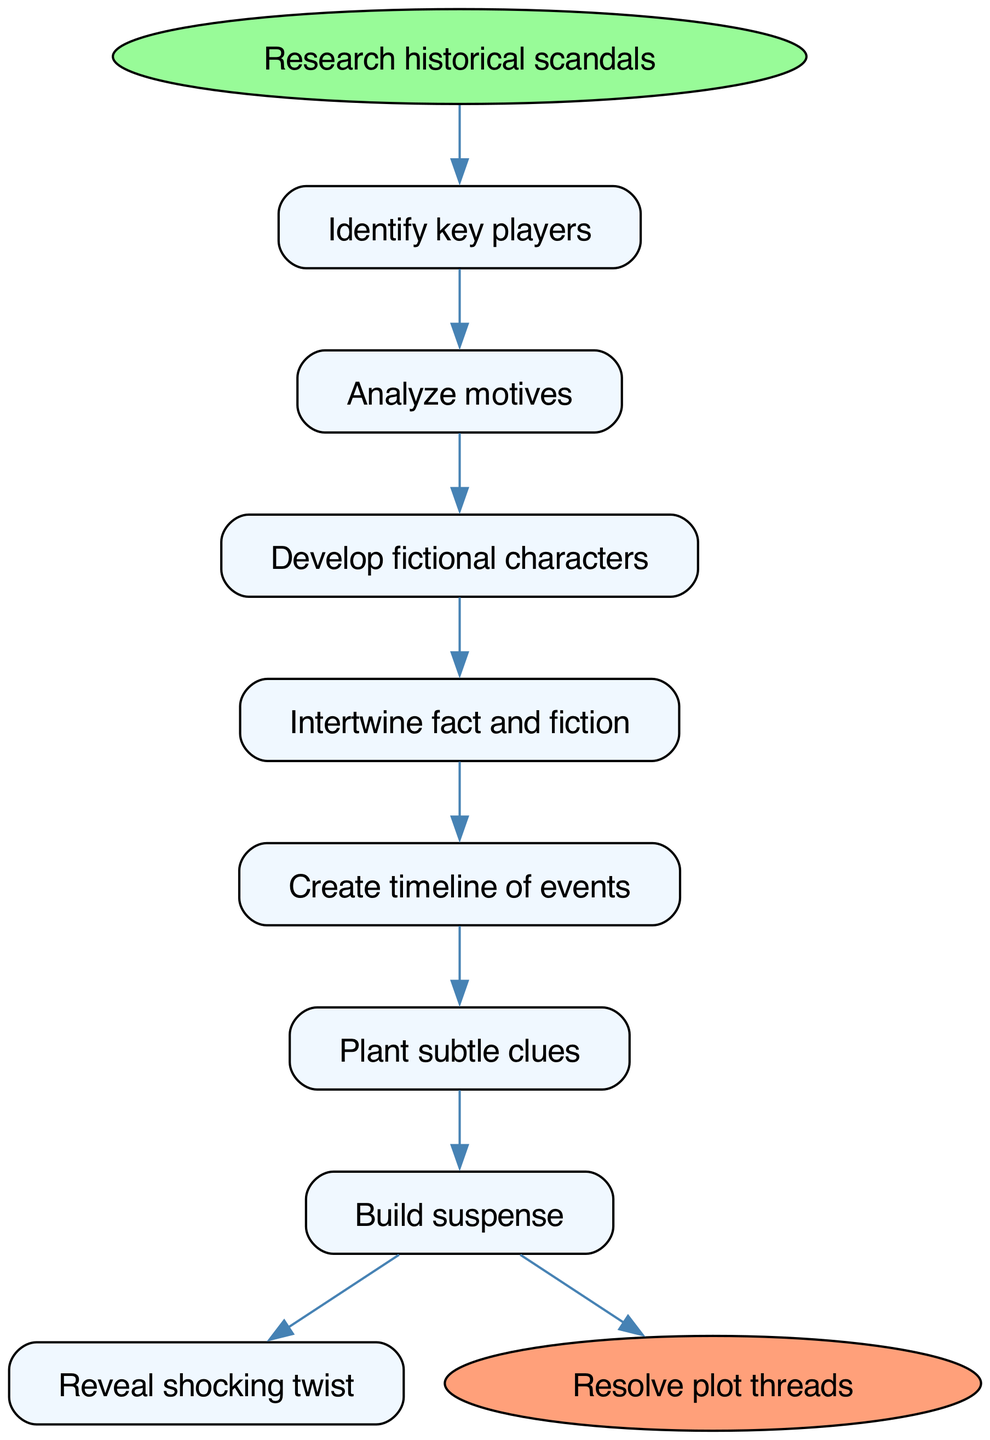What is the first step in the flowchart? The flowchart starts with the "Research historical scandals" step, which is the initial action to be taken before proceeding to the next steps.
Answer: Research historical scandals What is the last step before resolving plot threads? The last step before reaching the end, "Resolve plot threads," is "Reveal shocking twist," indicating what precedes the conclusion of the story.
Answer: Reveal shocking twist How many total steps are there in the process? Counting the steps listed in the diagram, there are seven sequential steps between the start and end nodes, including both initial and concluding actions.
Answer: Seven Which step comes directly after "Intertwine fact and fiction"? The step that follows "Intertwine fact and fiction" is "Create timeline of events," indicating the flow direction from the former to the latter.
Answer: Create timeline of events What are the last two steps in the flowchart? The last two steps leading up to the end are "Build suspense" followed by "Reveal shocking twist," which shows the climax of the tension-building process.
Answer: Build suspense, Reveal shocking twist What action immediately precedes "Plant subtle clues"? Prior to "Plant subtle clues," the action described is "Create timeline of events," establishing the necessary historical context.
Answer: Create timeline of events Which step explains character development in the flow? The step that deals with character development is "Develop fictional characters," which occurs after analyzing motives.
Answer: Develop fictional characters What is the relationship between "Analyze motives" and "Identify key players"? "Analyze motives" is the step that follows "Identify key players," showing a direct progression in the flow of the process.
Answer: Analyze motives follows Identify key players What is the primary function of the step "Build suspense"? The primary function of "Build suspense" is to create tension within the plot leading to the climax, which is crucial for maintaining reader interest.
Answer: Create tension 